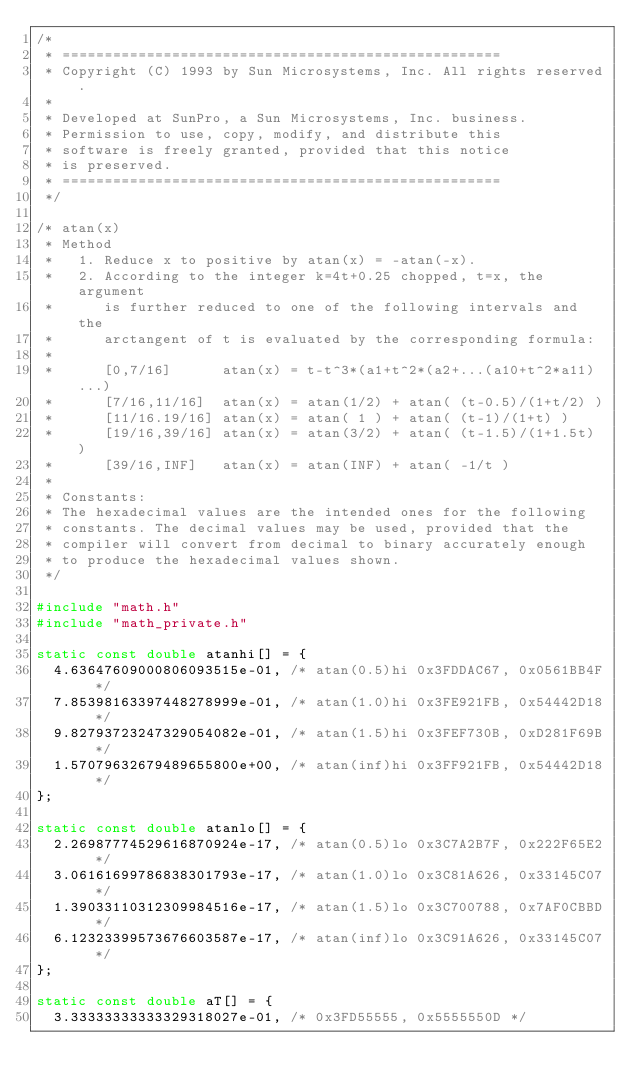Convert code to text. <code><loc_0><loc_0><loc_500><loc_500><_C_>/*
 * ====================================================
 * Copyright (C) 1993 by Sun Microsystems, Inc. All rights reserved.
 *
 * Developed at SunPro, a Sun Microsystems, Inc. business.
 * Permission to use, copy, modify, and distribute this
 * software is freely granted, provided that this notice
 * is preserved.
 * ====================================================
 */

/* atan(x)
 * Method
 *   1. Reduce x to positive by atan(x) = -atan(-x).
 *   2. According to the integer k=4t+0.25 chopped, t=x, the argument
 *      is further reduced to one of the following intervals and the
 *      arctangent of t is evaluated by the corresponding formula:
 *
 *      [0,7/16]      atan(x) = t-t^3*(a1+t^2*(a2+...(a10+t^2*a11)...)
 *      [7/16,11/16]  atan(x) = atan(1/2) + atan( (t-0.5)/(1+t/2) )
 *      [11/16.19/16] atan(x) = atan( 1 ) + atan( (t-1)/(1+t) )
 *      [19/16,39/16] atan(x) = atan(3/2) + atan( (t-1.5)/(1+1.5t) )
 *      [39/16,INF]   atan(x) = atan(INF) + atan( -1/t )
 *
 * Constants:
 * The hexadecimal values are the intended ones for the following
 * constants. The decimal values may be used, provided that the
 * compiler will convert from decimal to binary accurately enough
 * to produce the hexadecimal values shown.
 */

#include "math.h"
#include "math_private.h"

static const double atanhi[] = {
  4.63647609000806093515e-01, /* atan(0.5)hi 0x3FDDAC67, 0x0561BB4F */
  7.85398163397448278999e-01, /* atan(1.0)hi 0x3FE921FB, 0x54442D18 */
  9.82793723247329054082e-01, /* atan(1.5)hi 0x3FEF730B, 0xD281F69B */
  1.57079632679489655800e+00, /* atan(inf)hi 0x3FF921FB, 0x54442D18 */
};

static const double atanlo[] = {
  2.26987774529616870924e-17, /* atan(0.5)lo 0x3C7A2B7F, 0x222F65E2 */
  3.06161699786838301793e-17, /* atan(1.0)lo 0x3C81A626, 0x33145C07 */
  1.39033110312309984516e-17, /* atan(1.5)lo 0x3C700788, 0x7AF0CBBD */
  6.12323399573676603587e-17, /* atan(inf)lo 0x3C91A626, 0x33145C07 */
};

static const double aT[] = {
  3.33333333333329318027e-01, /* 0x3FD55555, 0x5555550D */</code> 